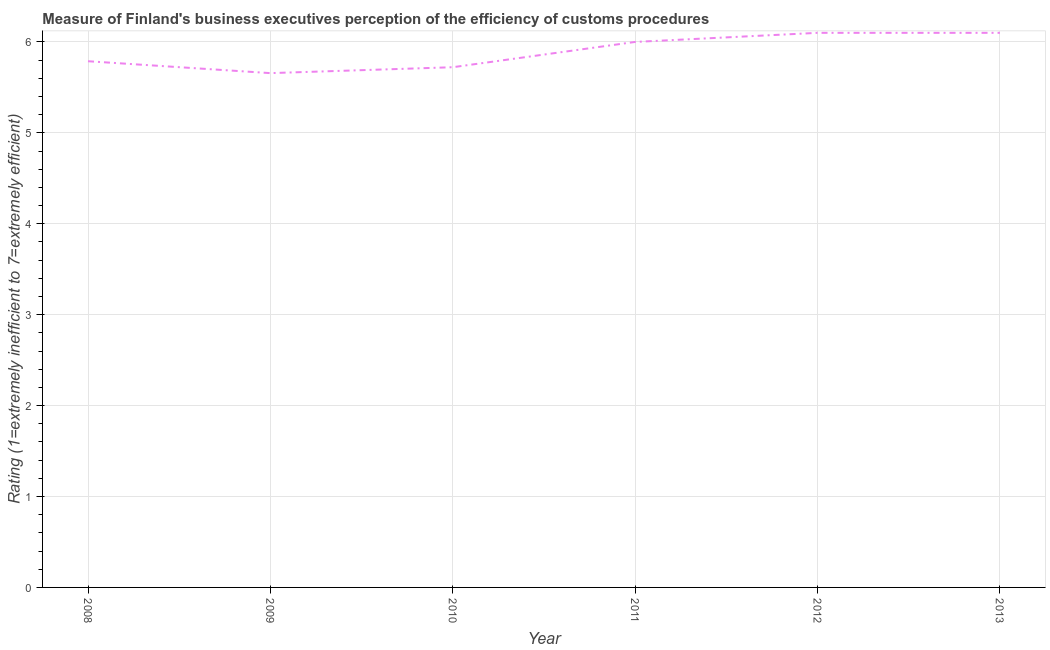What is the rating measuring burden of customs procedure in 2012?
Your response must be concise. 6.1. Across all years, what is the maximum rating measuring burden of customs procedure?
Give a very brief answer. 6.1. Across all years, what is the minimum rating measuring burden of customs procedure?
Give a very brief answer. 5.66. In which year was the rating measuring burden of customs procedure minimum?
Offer a terse response. 2009. What is the sum of the rating measuring burden of customs procedure?
Provide a short and direct response. 35.37. What is the difference between the rating measuring burden of customs procedure in 2008 and 2012?
Provide a short and direct response. -0.31. What is the average rating measuring burden of customs procedure per year?
Provide a short and direct response. 5.89. What is the median rating measuring burden of customs procedure?
Your answer should be compact. 5.89. What is the ratio of the rating measuring burden of customs procedure in 2008 to that in 2009?
Offer a very short reply. 1.02. Is the difference between the rating measuring burden of customs procedure in 2011 and 2013 greater than the difference between any two years?
Give a very brief answer. No. What is the difference between the highest and the second highest rating measuring burden of customs procedure?
Give a very brief answer. 0. What is the difference between the highest and the lowest rating measuring burden of customs procedure?
Offer a very short reply. 0.44. In how many years, is the rating measuring burden of customs procedure greater than the average rating measuring burden of customs procedure taken over all years?
Your answer should be compact. 3. How many lines are there?
Provide a short and direct response. 1. Are the values on the major ticks of Y-axis written in scientific E-notation?
Offer a terse response. No. What is the title of the graph?
Make the answer very short. Measure of Finland's business executives perception of the efficiency of customs procedures. What is the label or title of the X-axis?
Give a very brief answer. Year. What is the label or title of the Y-axis?
Keep it short and to the point. Rating (1=extremely inefficient to 7=extremely efficient). What is the Rating (1=extremely inefficient to 7=extremely efficient) in 2008?
Offer a very short reply. 5.79. What is the Rating (1=extremely inefficient to 7=extremely efficient) in 2009?
Offer a very short reply. 5.66. What is the Rating (1=extremely inefficient to 7=extremely efficient) in 2010?
Make the answer very short. 5.72. What is the Rating (1=extremely inefficient to 7=extremely efficient) of 2013?
Ensure brevity in your answer.  6.1. What is the difference between the Rating (1=extremely inefficient to 7=extremely efficient) in 2008 and 2009?
Give a very brief answer. 0.13. What is the difference between the Rating (1=extremely inefficient to 7=extremely efficient) in 2008 and 2010?
Your answer should be very brief. 0.07. What is the difference between the Rating (1=extremely inefficient to 7=extremely efficient) in 2008 and 2011?
Provide a short and direct response. -0.21. What is the difference between the Rating (1=extremely inefficient to 7=extremely efficient) in 2008 and 2012?
Your response must be concise. -0.31. What is the difference between the Rating (1=extremely inefficient to 7=extremely efficient) in 2008 and 2013?
Your answer should be very brief. -0.31. What is the difference between the Rating (1=extremely inefficient to 7=extremely efficient) in 2009 and 2010?
Ensure brevity in your answer.  -0.07. What is the difference between the Rating (1=extremely inefficient to 7=extremely efficient) in 2009 and 2011?
Provide a short and direct response. -0.34. What is the difference between the Rating (1=extremely inefficient to 7=extremely efficient) in 2009 and 2012?
Your response must be concise. -0.44. What is the difference between the Rating (1=extremely inefficient to 7=extremely efficient) in 2009 and 2013?
Your response must be concise. -0.44. What is the difference between the Rating (1=extremely inefficient to 7=extremely efficient) in 2010 and 2011?
Your answer should be very brief. -0.28. What is the difference between the Rating (1=extremely inefficient to 7=extremely efficient) in 2010 and 2012?
Offer a terse response. -0.38. What is the difference between the Rating (1=extremely inefficient to 7=extremely efficient) in 2010 and 2013?
Provide a succinct answer. -0.38. What is the difference between the Rating (1=extremely inefficient to 7=extremely efficient) in 2011 and 2012?
Give a very brief answer. -0.1. What is the difference between the Rating (1=extremely inefficient to 7=extremely efficient) in 2011 and 2013?
Provide a succinct answer. -0.1. What is the difference between the Rating (1=extremely inefficient to 7=extremely efficient) in 2012 and 2013?
Your response must be concise. 0. What is the ratio of the Rating (1=extremely inefficient to 7=extremely efficient) in 2008 to that in 2012?
Ensure brevity in your answer.  0.95. What is the ratio of the Rating (1=extremely inefficient to 7=extremely efficient) in 2008 to that in 2013?
Ensure brevity in your answer.  0.95. What is the ratio of the Rating (1=extremely inefficient to 7=extremely efficient) in 2009 to that in 2010?
Give a very brief answer. 0.99. What is the ratio of the Rating (1=extremely inefficient to 7=extremely efficient) in 2009 to that in 2011?
Your response must be concise. 0.94. What is the ratio of the Rating (1=extremely inefficient to 7=extremely efficient) in 2009 to that in 2012?
Give a very brief answer. 0.93. What is the ratio of the Rating (1=extremely inefficient to 7=extremely efficient) in 2009 to that in 2013?
Provide a short and direct response. 0.93. What is the ratio of the Rating (1=extremely inefficient to 7=extremely efficient) in 2010 to that in 2011?
Your answer should be very brief. 0.95. What is the ratio of the Rating (1=extremely inefficient to 7=extremely efficient) in 2010 to that in 2012?
Provide a succinct answer. 0.94. What is the ratio of the Rating (1=extremely inefficient to 7=extremely efficient) in 2010 to that in 2013?
Keep it short and to the point. 0.94. What is the ratio of the Rating (1=extremely inefficient to 7=extremely efficient) in 2011 to that in 2012?
Offer a very short reply. 0.98. What is the ratio of the Rating (1=extremely inefficient to 7=extremely efficient) in 2011 to that in 2013?
Your answer should be compact. 0.98. What is the ratio of the Rating (1=extremely inefficient to 7=extremely efficient) in 2012 to that in 2013?
Offer a terse response. 1. 